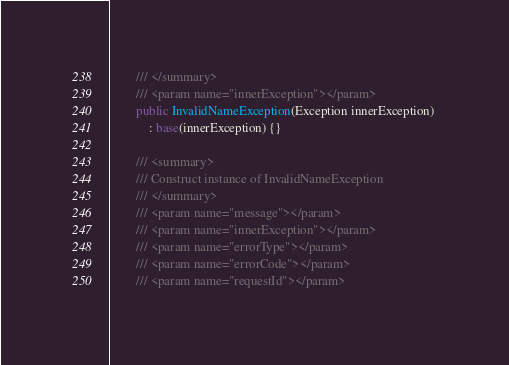Convert code to text. <code><loc_0><loc_0><loc_500><loc_500><_C#_>        /// </summary>
        /// <param name="innerException"></param>
        public InvalidNameException(Exception innerException) 
            : base(innerException) {}

        /// <summary>
        /// Construct instance of InvalidNameException
        /// </summary>
        /// <param name="message"></param>
        /// <param name="innerException"></param>
        /// <param name="errorType"></param>
        /// <param name="errorCode"></param>
        /// <param name="requestId"></param></code> 